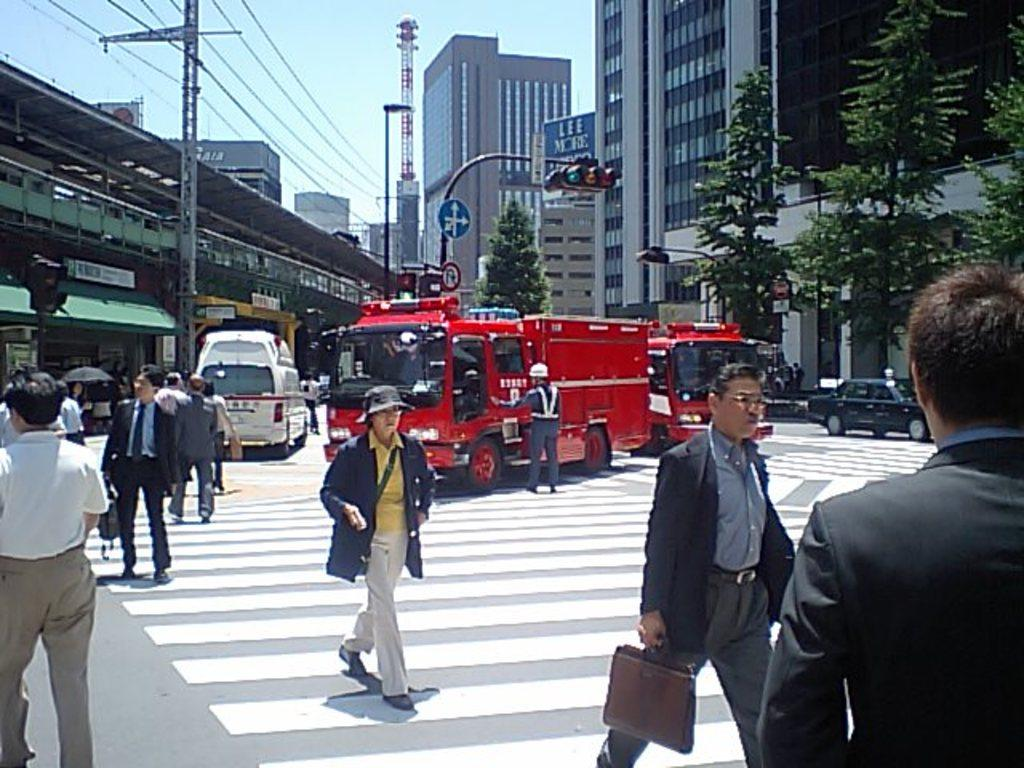What type of structures can be seen in the image? There are buildings in the image. Who or what else is present in the image? There are people and vehicles in the image. What else can be seen in the image besides buildings, people, and vehicles? There are trees, traffic lights, and poles in the image. What can be seen in the background of the image? A: The sky is visible in the background of the image. Can you tell me how many bags of popcorn are being sold by the fireman in the image? There is no fireman or popcorn present in the image. What type of trouble are the people in the image facing? There is no indication of trouble in the image; it simply shows buildings, people, vehicles, trees, traffic lights, poles, and the sky. 